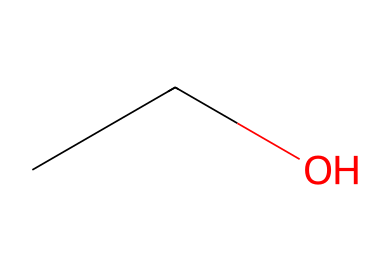What is the common name of this chemical? The SMILES representation "CCO" corresponds to ethanol, which is commonly known as alcohol.
Answer: ethanol How many carbon atoms are in this molecule? The SMILES "CCO" indicates two carbon atoms (the two "C" characters at the start), represented as a structure with a straight chain.
Answer: 2 How many hydrogen atoms are in this molecule? Each carbon in the structure typically binds to enough hydrogen to satisfy carbon's tetravalency. The two carbons and one oxygen result in a total of six hydrogen atoms.
Answer: 6 What type of functional group does this chemical contain? The "O" at the end of the SMILES indicates the presence of a hydroxyl group (-OH), which classifies this compound as an alcohol.
Answer: hydroxyl Does this chemical have any properties that indicate it is flammable? Ethanol is known to be a flammable liquid due to its structure; it contains C-H bonds that can readily combust.
Answer: yes What is the boiling point of this chemical? Ethanol typically has a boiling point around 78 degrees Celsius, which is characteristic for many alcohols.
Answer: 78 degrees Celsius How many bonds are present in the molecule? In the structure “CCO,” there are a total of five bonds: one bond between each carbon and the other carbon, two bonds between each carbon and its hydrogen, and one bond between the terminal carbon and the oxygen.
Answer: 5 